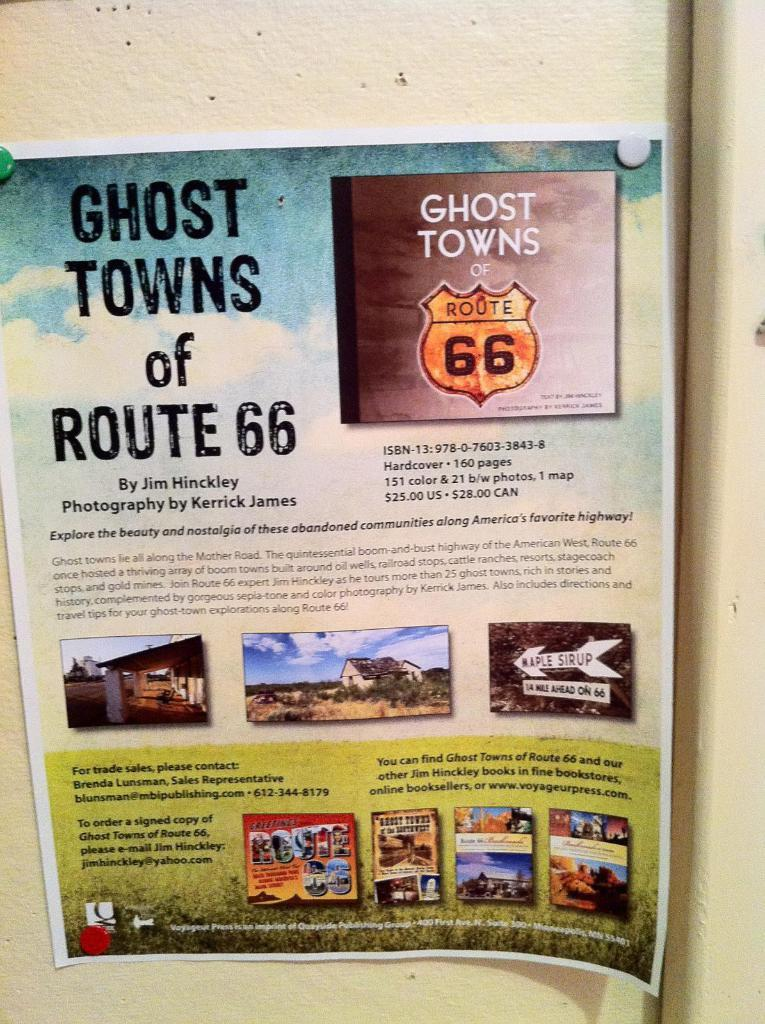Provide a one-sentence caption for the provided image. Poster on a wall that says "Ghost Towns of Route 66". 